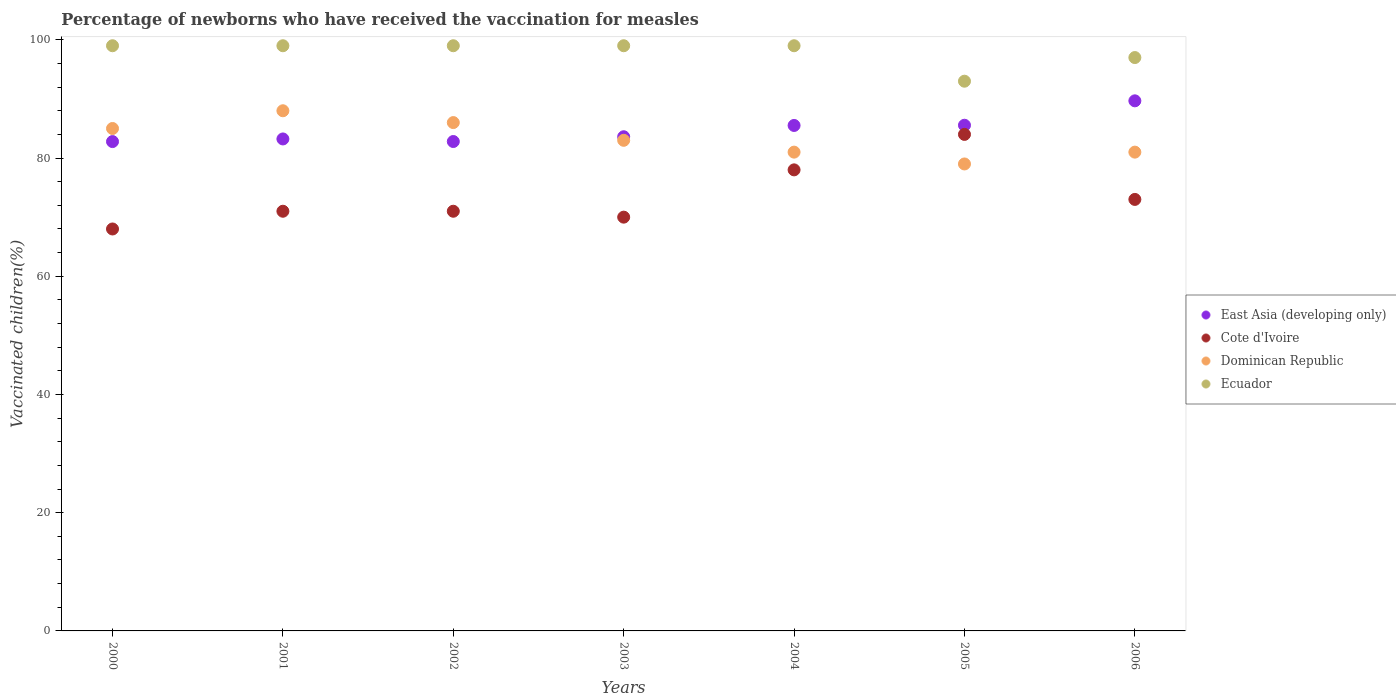How many different coloured dotlines are there?
Offer a terse response. 4. Is the number of dotlines equal to the number of legend labels?
Keep it short and to the point. Yes. What is the percentage of vaccinated children in Cote d'Ivoire in 2004?
Give a very brief answer. 78. Across all years, what is the maximum percentage of vaccinated children in East Asia (developing only)?
Keep it short and to the point. 89.68. What is the total percentage of vaccinated children in Ecuador in the graph?
Give a very brief answer. 685. What is the difference between the percentage of vaccinated children in Dominican Republic in 2004 and that in 2005?
Make the answer very short. 2. What is the difference between the percentage of vaccinated children in Cote d'Ivoire in 2006 and the percentage of vaccinated children in East Asia (developing only) in 2001?
Your answer should be very brief. -10.23. What is the average percentage of vaccinated children in Dominican Republic per year?
Ensure brevity in your answer.  83.29. What is the ratio of the percentage of vaccinated children in Cote d'Ivoire in 2001 to that in 2005?
Offer a terse response. 0.85. Is the percentage of vaccinated children in East Asia (developing only) in 2000 less than that in 2006?
Your answer should be compact. Yes. What is the difference between the highest and the second highest percentage of vaccinated children in East Asia (developing only)?
Offer a very short reply. 4.13. What is the difference between the highest and the lowest percentage of vaccinated children in Ecuador?
Ensure brevity in your answer.  6. Is it the case that in every year, the sum of the percentage of vaccinated children in East Asia (developing only) and percentage of vaccinated children in Dominican Republic  is greater than the percentage of vaccinated children in Ecuador?
Give a very brief answer. Yes. Does the percentage of vaccinated children in Dominican Republic monotonically increase over the years?
Offer a terse response. No. How many dotlines are there?
Make the answer very short. 4. What is the difference between two consecutive major ticks on the Y-axis?
Give a very brief answer. 20. Are the values on the major ticks of Y-axis written in scientific E-notation?
Give a very brief answer. No. Does the graph contain grids?
Your response must be concise. No. Where does the legend appear in the graph?
Provide a succinct answer. Center right. How are the legend labels stacked?
Offer a very short reply. Vertical. What is the title of the graph?
Ensure brevity in your answer.  Percentage of newborns who have received the vaccination for measles. Does "Estonia" appear as one of the legend labels in the graph?
Provide a succinct answer. No. What is the label or title of the Y-axis?
Provide a succinct answer. Vaccinated children(%). What is the Vaccinated children(%) of East Asia (developing only) in 2000?
Make the answer very short. 82.79. What is the Vaccinated children(%) of East Asia (developing only) in 2001?
Make the answer very short. 83.23. What is the Vaccinated children(%) in Cote d'Ivoire in 2001?
Your answer should be compact. 71. What is the Vaccinated children(%) in East Asia (developing only) in 2002?
Provide a succinct answer. 82.8. What is the Vaccinated children(%) of Dominican Republic in 2002?
Keep it short and to the point. 86. What is the Vaccinated children(%) of East Asia (developing only) in 2003?
Offer a terse response. 83.6. What is the Vaccinated children(%) in Dominican Republic in 2003?
Provide a short and direct response. 83. What is the Vaccinated children(%) of East Asia (developing only) in 2004?
Offer a terse response. 85.51. What is the Vaccinated children(%) of Dominican Republic in 2004?
Offer a very short reply. 81. What is the Vaccinated children(%) of East Asia (developing only) in 2005?
Offer a terse response. 85.55. What is the Vaccinated children(%) of Cote d'Ivoire in 2005?
Provide a succinct answer. 84. What is the Vaccinated children(%) in Dominican Republic in 2005?
Your response must be concise. 79. What is the Vaccinated children(%) in Ecuador in 2005?
Your answer should be compact. 93. What is the Vaccinated children(%) of East Asia (developing only) in 2006?
Your answer should be very brief. 89.68. What is the Vaccinated children(%) in Ecuador in 2006?
Make the answer very short. 97. Across all years, what is the maximum Vaccinated children(%) of East Asia (developing only)?
Give a very brief answer. 89.68. Across all years, what is the maximum Vaccinated children(%) of Cote d'Ivoire?
Provide a succinct answer. 84. Across all years, what is the maximum Vaccinated children(%) in Ecuador?
Provide a succinct answer. 99. Across all years, what is the minimum Vaccinated children(%) of East Asia (developing only)?
Offer a very short reply. 82.79. Across all years, what is the minimum Vaccinated children(%) of Dominican Republic?
Offer a very short reply. 79. Across all years, what is the minimum Vaccinated children(%) of Ecuador?
Make the answer very short. 93. What is the total Vaccinated children(%) of East Asia (developing only) in the graph?
Offer a terse response. 593.16. What is the total Vaccinated children(%) of Cote d'Ivoire in the graph?
Offer a very short reply. 515. What is the total Vaccinated children(%) in Dominican Republic in the graph?
Offer a very short reply. 583. What is the total Vaccinated children(%) of Ecuador in the graph?
Give a very brief answer. 685. What is the difference between the Vaccinated children(%) of East Asia (developing only) in 2000 and that in 2001?
Provide a short and direct response. -0.44. What is the difference between the Vaccinated children(%) in Ecuador in 2000 and that in 2001?
Make the answer very short. 0. What is the difference between the Vaccinated children(%) in East Asia (developing only) in 2000 and that in 2002?
Provide a succinct answer. -0.01. What is the difference between the Vaccinated children(%) of Cote d'Ivoire in 2000 and that in 2002?
Give a very brief answer. -3. What is the difference between the Vaccinated children(%) of Dominican Republic in 2000 and that in 2002?
Your answer should be compact. -1. What is the difference between the Vaccinated children(%) in Ecuador in 2000 and that in 2002?
Provide a succinct answer. 0. What is the difference between the Vaccinated children(%) in East Asia (developing only) in 2000 and that in 2003?
Offer a very short reply. -0.82. What is the difference between the Vaccinated children(%) in Dominican Republic in 2000 and that in 2003?
Make the answer very short. 2. What is the difference between the Vaccinated children(%) in East Asia (developing only) in 2000 and that in 2004?
Ensure brevity in your answer.  -2.73. What is the difference between the Vaccinated children(%) of Dominican Republic in 2000 and that in 2004?
Your answer should be very brief. 4. What is the difference between the Vaccinated children(%) in Ecuador in 2000 and that in 2004?
Ensure brevity in your answer.  0. What is the difference between the Vaccinated children(%) of East Asia (developing only) in 2000 and that in 2005?
Offer a very short reply. -2.76. What is the difference between the Vaccinated children(%) in Dominican Republic in 2000 and that in 2005?
Give a very brief answer. 6. What is the difference between the Vaccinated children(%) in Ecuador in 2000 and that in 2005?
Make the answer very short. 6. What is the difference between the Vaccinated children(%) of East Asia (developing only) in 2000 and that in 2006?
Provide a short and direct response. -6.89. What is the difference between the Vaccinated children(%) of Dominican Republic in 2000 and that in 2006?
Keep it short and to the point. 4. What is the difference between the Vaccinated children(%) in Ecuador in 2000 and that in 2006?
Provide a succinct answer. 2. What is the difference between the Vaccinated children(%) of East Asia (developing only) in 2001 and that in 2002?
Give a very brief answer. 0.43. What is the difference between the Vaccinated children(%) of Dominican Republic in 2001 and that in 2002?
Give a very brief answer. 2. What is the difference between the Vaccinated children(%) of East Asia (developing only) in 2001 and that in 2003?
Provide a succinct answer. -0.37. What is the difference between the Vaccinated children(%) of Dominican Republic in 2001 and that in 2003?
Give a very brief answer. 5. What is the difference between the Vaccinated children(%) in Ecuador in 2001 and that in 2003?
Keep it short and to the point. 0. What is the difference between the Vaccinated children(%) of East Asia (developing only) in 2001 and that in 2004?
Make the answer very short. -2.28. What is the difference between the Vaccinated children(%) of Dominican Republic in 2001 and that in 2004?
Your response must be concise. 7. What is the difference between the Vaccinated children(%) in Ecuador in 2001 and that in 2004?
Offer a very short reply. 0. What is the difference between the Vaccinated children(%) of East Asia (developing only) in 2001 and that in 2005?
Keep it short and to the point. -2.32. What is the difference between the Vaccinated children(%) of Dominican Republic in 2001 and that in 2005?
Provide a short and direct response. 9. What is the difference between the Vaccinated children(%) in East Asia (developing only) in 2001 and that in 2006?
Offer a terse response. -6.45. What is the difference between the Vaccinated children(%) in Cote d'Ivoire in 2001 and that in 2006?
Ensure brevity in your answer.  -2. What is the difference between the Vaccinated children(%) in Dominican Republic in 2001 and that in 2006?
Keep it short and to the point. 7. What is the difference between the Vaccinated children(%) in East Asia (developing only) in 2002 and that in 2003?
Ensure brevity in your answer.  -0.81. What is the difference between the Vaccinated children(%) of Dominican Republic in 2002 and that in 2003?
Provide a succinct answer. 3. What is the difference between the Vaccinated children(%) of East Asia (developing only) in 2002 and that in 2004?
Your answer should be very brief. -2.72. What is the difference between the Vaccinated children(%) of Cote d'Ivoire in 2002 and that in 2004?
Your answer should be very brief. -7. What is the difference between the Vaccinated children(%) of Dominican Republic in 2002 and that in 2004?
Give a very brief answer. 5. What is the difference between the Vaccinated children(%) in Ecuador in 2002 and that in 2004?
Make the answer very short. 0. What is the difference between the Vaccinated children(%) in East Asia (developing only) in 2002 and that in 2005?
Keep it short and to the point. -2.75. What is the difference between the Vaccinated children(%) in Dominican Republic in 2002 and that in 2005?
Make the answer very short. 7. What is the difference between the Vaccinated children(%) in East Asia (developing only) in 2002 and that in 2006?
Give a very brief answer. -6.88. What is the difference between the Vaccinated children(%) of Cote d'Ivoire in 2002 and that in 2006?
Make the answer very short. -2. What is the difference between the Vaccinated children(%) of Ecuador in 2002 and that in 2006?
Offer a very short reply. 2. What is the difference between the Vaccinated children(%) of East Asia (developing only) in 2003 and that in 2004?
Your answer should be very brief. -1.91. What is the difference between the Vaccinated children(%) in Ecuador in 2003 and that in 2004?
Keep it short and to the point. 0. What is the difference between the Vaccinated children(%) in East Asia (developing only) in 2003 and that in 2005?
Provide a short and direct response. -1.95. What is the difference between the Vaccinated children(%) of East Asia (developing only) in 2003 and that in 2006?
Ensure brevity in your answer.  -6.08. What is the difference between the Vaccinated children(%) in Cote d'Ivoire in 2003 and that in 2006?
Make the answer very short. -3. What is the difference between the Vaccinated children(%) in Dominican Republic in 2003 and that in 2006?
Provide a succinct answer. 2. What is the difference between the Vaccinated children(%) of Ecuador in 2003 and that in 2006?
Give a very brief answer. 2. What is the difference between the Vaccinated children(%) of East Asia (developing only) in 2004 and that in 2005?
Offer a terse response. -0.04. What is the difference between the Vaccinated children(%) of Cote d'Ivoire in 2004 and that in 2005?
Make the answer very short. -6. What is the difference between the Vaccinated children(%) of Ecuador in 2004 and that in 2005?
Your answer should be very brief. 6. What is the difference between the Vaccinated children(%) in East Asia (developing only) in 2004 and that in 2006?
Keep it short and to the point. -4.17. What is the difference between the Vaccinated children(%) in Ecuador in 2004 and that in 2006?
Offer a terse response. 2. What is the difference between the Vaccinated children(%) in East Asia (developing only) in 2005 and that in 2006?
Provide a succinct answer. -4.13. What is the difference between the Vaccinated children(%) of Dominican Republic in 2005 and that in 2006?
Your answer should be compact. -2. What is the difference between the Vaccinated children(%) of Ecuador in 2005 and that in 2006?
Offer a terse response. -4. What is the difference between the Vaccinated children(%) of East Asia (developing only) in 2000 and the Vaccinated children(%) of Cote d'Ivoire in 2001?
Your answer should be compact. 11.79. What is the difference between the Vaccinated children(%) in East Asia (developing only) in 2000 and the Vaccinated children(%) in Dominican Republic in 2001?
Your answer should be compact. -5.21. What is the difference between the Vaccinated children(%) in East Asia (developing only) in 2000 and the Vaccinated children(%) in Ecuador in 2001?
Provide a succinct answer. -16.21. What is the difference between the Vaccinated children(%) of Cote d'Ivoire in 2000 and the Vaccinated children(%) of Dominican Republic in 2001?
Offer a very short reply. -20. What is the difference between the Vaccinated children(%) in Cote d'Ivoire in 2000 and the Vaccinated children(%) in Ecuador in 2001?
Your answer should be compact. -31. What is the difference between the Vaccinated children(%) in East Asia (developing only) in 2000 and the Vaccinated children(%) in Cote d'Ivoire in 2002?
Your answer should be compact. 11.79. What is the difference between the Vaccinated children(%) in East Asia (developing only) in 2000 and the Vaccinated children(%) in Dominican Republic in 2002?
Keep it short and to the point. -3.21. What is the difference between the Vaccinated children(%) in East Asia (developing only) in 2000 and the Vaccinated children(%) in Ecuador in 2002?
Provide a succinct answer. -16.21. What is the difference between the Vaccinated children(%) of Cote d'Ivoire in 2000 and the Vaccinated children(%) of Dominican Republic in 2002?
Your response must be concise. -18. What is the difference between the Vaccinated children(%) in Cote d'Ivoire in 2000 and the Vaccinated children(%) in Ecuador in 2002?
Keep it short and to the point. -31. What is the difference between the Vaccinated children(%) of East Asia (developing only) in 2000 and the Vaccinated children(%) of Cote d'Ivoire in 2003?
Ensure brevity in your answer.  12.79. What is the difference between the Vaccinated children(%) in East Asia (developing only) in 2000 and the Vaccinated children(%) in Dominican Republic in 2003?
Your answer should be compact. -0.21. What is the difference between the Vaccinated children(%) of East Asia (developing only) in 2000 and the Vaccinated children(%) of Ecuador in 2003?
Give a very brief answer. -16.21. What is the difference between the Vaccinated children(%) in Cote d'Ivoire in 2000 and the Vaccinated children(%) in Ecuador in 2003?
Give a very brief answer. -31. What is the difference between the Vaccinated children(%) of East Asia (developing only) in 2000 and the Vaccinated children(%) of Cote d'Ivoire in 2004?
Keep it short and to the point. 4.79. What is the difference between the Vaccinated children(%) of East Asia (developing only) in 2000 and the Vaccinated children(%) of Dominican Republic in 2004?
Your answer should be compact. 1.79. What is the difference between the Vaccinated children(%) in East Asia (developing only) in 2000 and the Vaccinated children(%) in Ecuador in 2004?
Your response must be concise. -16.21. What is the difference between the Vaccinated children(%) in Cote d'Ivoire in 2000 and the Vaccinated children(%) in Ecuador in 2004?
Your answer should be compact. -31. What is the difference between the Vaccinated children(%) of East Asia (developing only) in 2000 and the Vaccinated children(%) of Cote d'Ivoire in 2005?
Ensure brevity in your answer.  -1.21. What is the difference between the Vaccinated children(%) of East Asia (developing only) in 2000 and the Vaccinated children(%) of Dominican Republic in 2005?
Your response must be concise. 3.79. What is the difference between the Vaccinated children(%) of East Asia (developing only) in 2000 and the Vaccinated children(%) of Ecuador in 2005?
Make the answer very short. -10.21. What is the difference between the Vaccinated children(%) in Cote d'Ivoire in 2000 and the Vaccinated children(%) in Dominican Republic in 2005?
Ensure brevity in your answer.  -11. What is the difference between the Vaccinated children(%) in Dominican Republic in 2000 and the Vaccinated children(%) in Ecuador in 2005?
Provide a short and direct response. -8. What is the difference between the Vaccinated children(%) in East Asia (developing only) in 2000 and the Vaccinated children(%) in Cote d'Ivoire in 2006?
Make the answer very short. 9.79. What is the difference between the Vaccinated children(%) in East Asia (developing only) in 2000 and the Vaccinated children(%) in Dominican Republic in 2006?
Provide a short and direct response. 1.79. What is the difference between the Vaccinated children(%) of East Asia (developing only) in 2000 and the Vaccinated children(%) of Ecuador in 2006?
Make the answer very short. -14.21. What is the difference between the Vaccinated children(%) in Cote d'Ivoire in 2000 and the Vaccinated children(%) in Ecuador in 2006?
Keep it short and to the point. -29. What is the difference between the Vaccinated children(%) in East Asia (developing only) in 2001 and the Vaccinated children(%) in Cote d'Ivoire in 2002?
Make the answer very short. 12.23. What is the difference between the Vaccinated children(%) in East Asia (developing only) in 2001 and the Vaccinated children(%) in Dominican Republic in 2002?
Keep it short and to the point. -2.77. What is the difference between the Vaccinated children(%) in East Asia (developing only) in 2001 and the Vaccinated children(%) in Ecuador in 2002?
Make the answer very short. -15.77. What is the difference between the Vaccinated children(%) in Cote d'Ivoire in 2001 and the Vaccinated children(%) in Dominican Republic in 2002?
Provide a succinct answer. -15. What is the difference between the Vaccinated children(%) of Cote d'Ivoire in 2001 and the Vaccinated children(%) of Ecuador in 2002?
Offer a terse response. -28. What is the difference between the Vaccinated children(%) of East Asia (developing only) in 2001 and the Vaccinated children(%) of Cote d'Ivoire in 2003?
Your answer should be very brief. 13.23. What is the difference between the Vaccinated children(%) in East Asia (developing only) in 2001 and the Vaccinated children(%) in Dominican Republic in 2003?
Ensure brevity in your answer.  0.23. What is the difference between the Vaccinated children(%) of East Asia (developing only) in 2001 and the Vaccinated children(%) of Ecuador in 2003?
Your answer should be compact. -15.77. What is the difference between the Vaccinated children(%) in Cote d'Ivoire in 2001 and the Vaccinated children(%) in Ecuador in 2003?
Make the answer very short. -28. What is the difference between the Vaccinated children(%) in Dominican Republic in 2001 and the Vaccinated children(%) in Ecuador in 2003?
Offer a terse response. -11. What is the difference between the Vaccinated children(%) in East Asia (developing only) in 2001 and the Vaccinated children(%) in Cote d'Ivoire in 2004?
Provide a short and direct response. 5.23. What is the difference between the Vaccinated children(%) of East Asia (developing only) in 2001 and the Vaccinated children(%) of Dominican Republic in 2004?
Give a very brief answer. 2.23. What is the difference between the Vaccinated children(%) in East Asia (developing only) in 2001 and the Vaccinated children(%) in Ecuador in 2004?
Provide a short and direct response. -15.77. What is the difference between the Vaccinated children(%) in Cote d'Ivoire in 2001 and the Vaccinated children(%) in Ecuador in 2004?
Ensure brevity in your answer.  -28. What is the difference between the Vaccinated children(%) of Dominican Republic in 2001 and the Vaccinated children(%) of Ecuador in 2004?
Keep it short and to the point. -11. What is the difference between the Vaccinated children(%) in East Asia (developing only) in 2001 and the Vaccinated children(%) in Cote d'Ivoire in 2005?
Make the answer very short. -0.77. What is the difference between the Vaccinated children(%) in East Asia (developing only) in 2001 and the Vaccinated children(%) in Dominican Republic in 2005?
Keep it short and to the point. 4.23. What is the difference between the Vaccinated children(%) of East Asia (developing only) in 2001 and the Vaccinated children(%) of Ecuador in 2005?
Your response must be concise. -9.77. What is the difference between the Vaccinated children(%) of Cote d'Ivoire in 2001 and the Vaccinated children(%) of Dominican Republic in 2005?
Give a very brief answer. -8. What is the difference between the Vaccinated children(%) in Cote d'Ivoire in 2001 and the Vaccinated children(%) in Ecuador in 2005?
Your response must be concise. -22. What is the difference between the Vaccinated children(%) of Dominican Republic in 2001 and the Vaccinated children(%) of Ecuador in 2005?
Your answer should be very brief. -5. What is the difference between the Vaccinated children(%) in East Asia (developing only) in 2001 and the Vaccinated children(%) in Cote d'Ivoire in 2006?
Give a very brief answer. 10.23. What is the difference between the Vaccinated children(%) of East Asia (developing only) in 2001 and the Vaccinated children(%) of Dominican Republic in 2006?
Provide a succinct answer. 2.23. What is the difference between the Vaccinated children(%) in East Asia (developing only) in 2001 and the Vaccinated children(%) in Ecuador in 2006?
Your answer should be very brief. -13.77. What is the difference between the Vaccinated children(%) in Cote d'Ivoire in 2001 and the Vaccinated children(%) in Ecuador in 2006?
Offer a very short reply. -26. What is the difference between the Vaccinated children(%) in Dominican Republic in 2001 and the Vaccinated children(%) in Ecuador in 2006?
Give a very brief answer. -9. What is the difference between the Vaccinated children(%) in East Asia (developing only) in 2002 and the Vaccinated children(%) in Cote d'Ivoire in 2003?
Your answer should be compact. 12.8. What is the difference between the Vaccinated children(%) of East Asia (developing only) in 2002 and the Vaccinated children(%) of Dominican Republic in 2003?
Offer a very short reply. -0.2. What is the difference between the Vaccinated children(%) in East Asia (developing only) in 2002 and the Vaccinated children(%) in Ecuador in 2003?
Ensure brevity in your answer.  -16.2. What is the difference between the Vaccinated children(%) of Cote d'Ivoire in 2002 and the Vaccinated children(%) of Dominican Republic in 2003?
Your response must be concise. -12. What is the difference between the Vaccinated children(%) of Dominican Republic in 2002 and the Vaccinated children(%) of Ecuador in 2003?
Your answer should be compact. -13. What is the difference between the Vaccinated children(%) in East Asia (developing only) in 2002 and the Vaccinated children(%) in Cote d'Ivoire in 2004?
Give a very brief answer. 4.8. What is the difference between the Vaccinated children(%) in East Asia (developing only) in 2002 and the Vaccinated children(%) in Dominican Republic in 2004?
Your answer should be very brief. 1.8. What is the difference between the Vaccinated children(%) of East Asia (developing only) in 2002 and the Vaccinated children(%) of Ecuador in 2004?
Provide a short and direct response. -16.2. What is the difference between the Vaccinated children(%) of East Asia (developing only) in 2002 and the Vaccinated children(%) of Cote d'Ivoire in 2005?
Give a very brief answer. -1.2. What is the difference between the Vaccinated children(%) of East Asia (developing only) in 2002 and the Vaccinated children(%) of Dominican Republic in 2005?
Give a very brief answer. 3.8. What is the difference between the Vaccinated children(%) in East Asia (developing only) in 2002 and the Vaccinated children(%) in Ecuador in 2005?
Keep it short and to the point. -10.2. What is the difference between the Vaccinated children(%) in Cote d'Ivoire in 2002 and the Vaccinated children(%) in Dominican Republic in 2005?
Keep it short and to the point. -8. What is the difference between the Vaccinated children(%) in Cote d'Ivoire in 2002 and the Vaccinated children(%) in Ecuador in 2005?
Your response must be concise. -22. What is the difference between the Vaccinated children(%) of Dominican Republic in 2002 and the Vaccinated children(%) of Ecuador in 2005?
Keep it short and to the point. -7. What is the difference between the Vaccinated children(%) in East Asia (developing only) in 2002 and the Vaccinated children(%) in Cote d'Ivoire in 2006?
Make the answer very short. 9.8. What is the difference between the Vaccinated children(%) of East Asia (developing only) in 2002 and the Vaccinated children(%) of Dominican Republic in 2006?
Keep it short and to the point. 1.8. What is the difference between the Vaccinated children(%) of East Asia (developing only) in 2002 and the Vaccinated children(%) of Ecuador in 2006?
Provide a short and direct response. -14.2. What is the difference between the Vaccinated children(%) of East Asia (developing only) in 2003 and the Vaccinated children(%) of Cote d'Ivoire in 2004?
Give a very brief answer. 5.6. What is the difference between the Vaccinated children(%) of East Asia (developing only) in 2003 and the Vaccinated children(%) of Dominican Republic in 2004?
Your answer should be very brief. 2.6. What is the difference between the Vaccinated children(%) in East Asia (developing only) in 2003 and the Vaccinated children(%) in Ecuador in 2004?
Provide a succinct answer. -15.4. What is the difference between the Vaccinated children(%) in Cote d'Ivoire in 2003 and the Vaccinated children(%) in Dominican Republic in 2004?
Your response must be concise. -11. What is the difference between the Vaccinated children(%) of Cote d'Ivoire in 2003 and the Vaccinated children(%) of Ecuador in 2004?
Offer a very short reply. -29. What is the difference between the Vaccinated children(%) in Dominican Republic in 2003 and the Vaccinated children(%) in Ecuador in 2004?
Provide a short and direct response. -16. What is the difference between the Vaccinated children(%) of East Asia (developing only) in 2003 and the Vaccinated children(%) of Cote d'Ivoire in 2005?
Your answer should be very brief. -0.4. What is the difference between the Vaccinated children(%) of East Asia (developing only) in 2003 and the Vaccinated children(%) of Dominican Republic in 2005?
Provide a short and direct response. 4.6. What is the difference between the Vaccinated children(%) in East Asia (developing only) in 2003 and the Vaccinated children(%) in Ecuador in 2005?
Offer a terse response. -9.4. What is the difference between the Vaccinated children(%) in Cote d'Ivoire in 2003 and the Vaccinated children(%) in Dominican Republic in 2005?
Provide a succinct answer. -9. What is the difference between the Vaccinated children(%) of Cote d'Ivoire in 2003 and the Vaccinated children(%) of Ecuador in 2005?
Your answer should be very brief. -23. What is the difference between the Vaccinated children(%) of Dominican Republic in 2003 and the Vaccinated children(%) of Ecuador in 2005?
Keep it short and to the point. -10. What is the difference between the Vaccinated children(%) in East Asia (developing only) in 2003 and the Vaccinated children(%) in Cote d'Ivoire in 2006?
Offer a terse response. 10.6. What is the difference between the Vaccinated children(%) of East Asia (developing only) in 2003 and the Vaccinated children(%) of Dominican Republic in 2006?
Keep it short and to the point. 2.6. What is the difference between the Vaccinated children(%) in East Asia (developing only) in 2003 and the Vaccinated children(%) in Ecuador in 2006?
Your response must be concise. -13.4. What is the difference between the Vaccinated children(%) of Cote d'Ivoire in 2003 and the Vaccinated children(%) of Ecuador in 2006?
Give a very brief answer. -27. What is the difference between the Vaccinated children(%) in Dominican Republic in 2003 and the Vaccinated children(%) in Ecuador in 2006?
Offer a terse response. -14. What is the difference between the Vaccinated children(%) in East Asia (developing only) in 2004 and the Vaccinated children(%) in Cote d'Ivoire in 2005?
Your answer should be very brief. 1.51. What is the difference between the Vaccinated children(%) in East Asia (developing only) in 2004 and the Vaccinated children(%) in Dominican Republic in 2005?
Your answer should be compact. 6.51. What is the difference between the Vaccinated children(%) of East Asia (developing only) in 2004 and the Vaccinated children(%) of Ecuador in 2005?
Your answer should be very brief. -7.49. What is the difference between the Vaccinated children(%) in Cote d'Ivoire in 2004 and the Vaccinated children(%) in Ecuador in 2005?
Offer a terse response. -15. What is the difference between the Vaccinated children(%) in East Asia (developing only) in 2004 and the Vaccinated children(%) in Cote d'Ivoire in 2006?
Your answer should be very brief. 12.51. What is the difference between the Vaccinated children(%) of East Asia (developing only) in 2004 and the Vaccinated children(%) of Dominican Republic in 2006?
Your response must be concise. 4.51. What is the difference between the Vaccinated children(%) in East Asia (developing only) in 2004 and the Vaccinated children(%) in Ecuador in 2006?
Ensure brevity in your answer.  -11.49. What is the difference between the Vaccinated children(%) of Cote d'Ivoire in 2004 and the Vaccinated children(%) of Dominican Republic in 2006?
Keep it short and to the point. -3. What is the difference between the Vaccinated children(%) in Cote d'Ivoire in 2004 and the Vaccinated children(%) in Ecuador in 2006?
Provide a short and direct response. -19. What is the difference between the Vaccinated children(%) in Dominican Republic in 2004 and the Vaccinated children(%) in Ecuador in 2006?
Keep it short and to the point. -16. What is the difference between the Vaccinated children(%) of East Asia (developing only) in 2005 and the Vaccinated children(%) of Cote d'Ivoire in 2006?
Your answer should be very brief. 12.55. What is the difference between the Vaccinated children(%) in East Asia (developing only) in 2005 and the Vaccinated children(%) in Dominican Republic in 2006?
Provide a succinct answer. 4.55. What is the difference between the Vaccinated children(%) of East Asia (developing only) in 2005 and the Vaccinated children(%) of Ecuador in 2006?
Your response must be concise. -11.45. What is the difference between the Vaccinated children(%) of Cote d'Ivoire in 2005 and the Vaccinated children(%) of Dominican Republic in 2006?
Give a very brief answer. 3. What is the difference between the Vaccinated children(%) in Dominican Republic in 2005 and the Vaccinated children(%) in Ecuador in 2006?
Provide a short and direct response. -18. What is the average Vaccinated children(%) of East Asia (developing only) per year?
Your response must be concise. 84.74. What is the average Vaccinated children(%) in Cote d'Ivoire per year?
Make the answer very short. 73.57. What is the average Vaccinated children(%) in Dominican Republic per year?
Your answer should be compact. 83.29. What is the average Vaccinated children(%) in Ecuador per year?
Keep it short and to the point. 97.86. In the year 2000, what is the difference between the Vaccinated children(%) in East Asia (developing only) and Vaccinated children(%) in Cote d'Ivoire?
Make the answer very short. 14.79. In the year 2000, what is the difference between the Vaccinated children(%) of East Asia (developing only) and Vaccinated children(%) of Dominican Republic?
Give a very brief answer. -2.21. In the year 2000, what is the difference between the Vaccinated children(%) in East Asia (developing only) and Vaccinated children(%) in Ecuador?
Your response must be concise. -16.21. In the year 2000, what is the difference between the Vaccinated children(%) in Cote d'Ivoire and Vaccinated children(%) in Ecuador?
Provide a succinct answer. -31. In the year 2001, what is the difference between the Vaccinated children(%) of East Asia (developing only) and Vaccinated children(%) of Cote d'Ivoire?
Provide a succinct answer. 12.23. In the year 2001, what is the difference between the Vaccinated children(%) of East Asia (developing only) and Vaccinated children(%) of Dominican Republic?
Your answer should be very brief. -4.77. In the year 2001, what is the difference between the Vaccinated children(%) in East Asia (developing only) and Vaccinated children(%) in Ecuador?
Your response must be concise. -15.77. In the year 2002, what is the difference between the Vaccinated children(%) in East Asia (developing only) and Vaccinated children(%) in Cote d'Ivoire?
Ensure brevity in your answer.  11.8. In the year 2002, what is the difference between the Vaccinated children(%) of East Asia (developing only) and Vaccinated children(%) of Dominican Republic?
Your response must be concise. -3.2. In the year 2002, what is the difference between the Vaccinated children(%) of East Asia (developing only) and Vaccinated children(%) of Ecuador?
Give a very brief answer. -16.2. In the year 2002, what is the difference between the Vaccinated children(%) of Cote d'Ivoire and Vaccinated children(%) of Dominican Republic?
Provide a succinct answer. -15. In the year 2002, what is the difference between the Vaccinated children(%) in Cote d'Ivoire and Vaccinated children(%) in Ecuador?
Your answer should be compact. -28. In the year 2002, what is the difference between the Vaccinated children(%) of Dominican Republic and Vaccinated children(%) of Ecuador?
Ensure brevity in your answer.  -13. In the year 2003, what is the difference between the Vaccinated children(%) of East Asia (developing only) and Vaccinated children(%) of Cote d'Ivoire?
Ensure brevity in your answer.  13.6. In the year 2003, what is the difference between the Vaccinated children(%) in East Asia (developing only) and Vaccinated children(%) in Dominican Republic?
Keep it short and to the point. 0.6. In the year 2003, what is the difference between the Vaccinated children(%) of East Asia (developing only) and Vaccinated children(%) of Ecuador?
Your answer should be compact. -15.4. In the year 2003, what is the difference between the Vaccinated children(%) of Cote d'Ivoire and Vaccinated children(%) of Ecuador?
Offer a terse response. -29. In the year 2003, what is the difference between the Vaccinated children(%) of Dominican Republic and Vaccinated children(%) of Ecuador?
Your answer should be very brief. -16. In the year 2004, what is the difference between the Vaccinated children(%) of East Asia (developing only) and Vaccinated children(%) of Cote d'Ivoire?
Ensure brevity in your answer.  7.51. In the year 2004, what is the difference between the Vaccinated children(%) in East Asia (developing only) and Vaccinated children(%) in Dominican Republic?
Ensure brevity in your answer.  4.51. In the year 2004, what is the difference between the Vaccinated children(%) of East Asia (developing only) and Vaccinated children(%) of Ecuador?
Your answer should be compact. -13.49. In the year 2004, what is the difference between the Vaccinated children(%) of Cote d'Ivoire and Vaccinated children(%) of Dominican Republic?
Offer a very short reply. -3. In the year 2004, what is the difference between the Vaccinated children(%) in Dominican Republic and Vaccinated children(%) in Ecuador?
Ensure brevity in your answer.  -18. In the year 2005, what is the difference between the Vaccinated children(%) of East Asia (developing only) and Vaccinated children(%) of Cote d'Ivoire?
Your answer should be very brief. 1.55. In the year 2005, what is the difference between the Vaccinated children(%) of East Asia (developing only) and Vaccinated children(%) of Dominican Republic?
Provide a succinct answer. 6.55. In the year 2005, what is the difference between the Vaccinated children(%) of East Asia (developing only) and Vaccinated children(%) of Ecuador?
Provide a short and direct response. -7.45. In the year 2006, what is the difference between the Vaccinated children(%) in East Asia (developing only) and Vaccinated children(%) in Cote d'Ivoire?
Make the answer very short. 16.68. In the year 2006, what is the difference between the Vaccinated children(%) of East Asia (developing only) and Vaccinated children(%) of Dominican Republic?
Your answer should be very brief. 8.68. In the year 2006, what is the difference between the Vaccinated children(%) in East Asia (developing only) and Vaccinated children(%) in Ecuador?
Ensure brevity in your answer.  -7.32. In the year 2006, what is the difference between the Vaccinated children(%) in Cote d'Ivoire and Vaccinated children(%) in Dominican Republic?
Your answer should be compact. -8. What is the ratio of the Vaccinated children(%) of Cote d'Ivoire in 2000 to that in 2001?
Offer a very short reply. 0.96. What is the ratio of the Vaccinated children(%) of Dominican Republic in 2000 to that in 2001?
Provide a succinct answer. 0.97. What is the ratio of the Vaccinated children(%) of Ecuador in 2000 to that in 2001?
Offer a very short reply. 1. What is the ratio of the Vaccinated children(%) in Cote d'Ivoire in 2000 to that in 2002?
Your response must be concise. 0.96. What is the ratio of the Vaccinated children(%) of Dominican Republic in 2000 to that in 2002?
Your answer should be compact. 0.99. What is the ratio of the Vaccinated children(%) in East Asia (developing only) in 2000 to that in 2003?
Your answer should be compact. 0.99. What is the ratio of the Vaccinated children(%) of Cote d'Ivoire in 2000 to that in 2003?
Provide a short and direct response. 0.97. What is the ratio of the Vaccinated children(%) of Dominican Republic in 2000 to that in 2003?
Your answer should be very brief. 1.02. What is the ratio of the Vaccinated children(%) in East Asia (developing only) in 2000 to that in 2004?
Your answer should be very brief. 0.97. What is the ratio of the Vaccinated children(%) of Cote d'Ivoire in 2000 to that in 2004?
Provide a short and direct response. 0.87. What is the ratio of the Vaccinated children(%) of Dominican Republic in 2000 to that in 2004?
Give a very brief answer. 1.05. What is the ratio of the Vaccinated children(%) of Ecuador in 2000 to that in 2004?
Your response must be concise. 1. What is the ratio of the Vaccinated children(%) in East Asia (developing only) in 2000 to that in 2005?
Offer a very short reply. 0.97. What is the ratio of the Vaccinated children(%) of Cote d'Ivoire in 2000 to that in 2005?
Your response must be concise. 0.81. What is the ratio of the Vaccinated children(%) of Dominican Republic in 2000 to that in 2005?
Offer a terse response. 1.08. What is the ratio of the Vaccinated children(%) of Ecuador in 2000 to that in 2005?
Provide a succinct answer. 1.06. What is the ratio of the Vaccinated children(%) of Cote d'Ivoire in 2000 to that in 2006?
Provide a succinct answer. 0.93. What is the ratio of the Vaccinated children(%) of Dominican Republic in 2000 to that in 2006?
Keep it short and to the point. 1.05. What is the ratio of the Vaccinated children(%) of Ecuador in 2000 to that in 2006?
Ensure brevity in your answer.  1.02. What is the ratio of the Vaccinated children(%) of Dominican Republic in 2001 to that in 2002?
Offer a terse response. 1.02. What is the ratio of the Vaccinated children(%) in Ecuador in 2001 to that in 2002?
Your answer should be compact. 1. What is the ratio of the Vaccinated children(%) of Cote d'Ivoire in 2001 to that in 2003?
Make the answer very short. 1.01. What is the ratio of the Vaccinated children(%) in Dominican Republic in 2001 to that in 2003?
Keep it short and to the point. 1.06. What is the ratio of the Vaccinated children(%) in Ecuador in 2001 to that in 2003?
Provide a short and direct response. 1. What is the ratio of the Vaccinated children(%) of East Asia (developing only) in 2001 to that in 2004?
Provide a succinct answer. 0.97. What is the ratio of the Vaccinated children(%) of Cote d'Ivoire in 2001 to that in 2004?
Give a very brief answer. 0.91. What is the ratio of the Vaccinated children(%) of Dominican Republic in 2001 to that in 2004?
Make the answer very short. 1.09. What is the ratio of the Vaccinated children(%) of East Asia (developing only) in 2001 to that in 2005?
Give a very brief answer. 0.97. What is the ratio of the Vaccinated children(%) in Cote d'Ivoire in 2001 to that in 2005?
Keep it short and to the point. 0.85. What is the ratio of the Vaccinated children(%) in Dominican Republic in 2001 to that in 2005?
Provide a succinct answer. 1.11. What is the ratio of the Vaccinated children(%) of Ecuador in 2001 to that in 2005?
Ensure brevity in your answer.  1.06. What is the ratio of the Vaccinated children(%) in East Asia (developing only) in 2001 to that in 2006?
Give a very brief answer. 0.93. What is the ratio of the Vaccinated children(%) of Cote d'Ivoire in 2001 to that in 2006?
Provide a short and direct response. 0.97. What is the ratio of the Vaccinated children(%) in Dominican Republic in 2001 to that in 2006?
Keep it short and to the point. 1.09. What is the ratio of the Vaccinated children(%) in Ecuador in 2001 to that in 2006?
Give a very brief answer. 1.02. What is the ratio of the Vaccinated children(%) in Cote d'Ivoire in 2002 to that in 2003?
Make the answer very short. 1.01. What is the ratio of the Vaccinated children(%) of Dominican Republic in 2002 to that in 2003?
Keep it short and to the point. 1.04. What is the ratio of the Vaccinated children(%) in East Asia (developing only) in 2002 to that in 2004?
Ensure brevity in your answer.  0.97. What is the ratio of the Vaccinated children(%) of Cote d'Ivoire in 2002 to that in 2004?
Your answer should be compact. 0.91. What is the ratio of the Vaccinated children(%) in Dominican Republic in 2002 to that in 2004?
Your response must be concise. 1.06. What is the ratio of the Vaccinated children(%) in East Asia (developing only) in 2002 to that in 2005?
Keep it short and to the point. 0.97. What is the ratio of the Vaccinated children(%) in Cote d'Ivoire in 2002 to that in 2005?
Offer a terse response. 0.85. What is the ratio of the Vaccinated children(%) in Dominican Republic in 2002 to that in 2005?
Make the answer very short. 1.09. What is the ratio of the Vaccinated children(%) in Ecuador in 2002 to that in 2005?
Your answer should be very brief. 1.06. What is the ratio of the Vaccinated children(%) in East Asia (developing only) in 2002 to that in 2006?
Your answer should be compact. 0.92. What is the ratio of the Vaccinated children(%) in Cote d'Ivoire in 2002 to that in 2006?
Your response must be concise. 0.97. What is the ratio of the Vaccinated children(%) of Dominican Republic in 2002 to that in 2006?
Provide a succinct answer. 1.06. What is the ratio of the Vaccinated children(%) of Ecuador in 2002 to that in 2006?
Give a very brief answer. 1.02. What is the ratio of the Vaccinated children(%) in East Asia (developing only) in 2003 to that in 2004?
Your answer should be compact. 0.98. What is the ratio of the Vaccinated children(%) in Cote d'Ivoire in 2003 to that in 2004?
Provide a short and direct response. 0.9. What is the ratio of the Vaccinated children(%) in Dominican Republic in 2003 to that in 2004?
Offer a terse response. 1.02. What is the ratio of the Vaccinated children(%) of East Asia (developing only) in 2003 to that in 2005?
Keep it short and to the point. 0.98. What is the ratio of the Vaccinated children(%) of Dominican Republic in 2003 to that in 2005?
Provide a short and direct response. 1.05. What is the ratio of the Vaccinated children(%) of Ecuador in 2003 to that in 2005?
Your answer should be compact. 1.06. What is the ratio of the Vaccinated children(%) of East Asia (developing only) in 2003 to that in 2006?
Keep it short and to the point. 0.93. What is the ratio of the Vaccinated children(%) in Cote d'Ivoire in 2003 to that in 2006?
Your answer should be very brief. 0.96. What is the ratio of the Vaccinated children(%) of Dominican Republic in 2003 to that in 2006?
Offer a very short reply. 1.02. What is the ratio of the Vaccinated children(%) in Ecuador in 2003 to that in 2006?
Provide a short and direct response. 1.02. What is the ratio of the Vaccinated children(%) of East Asia (developing only) in 2004 to that in 2005?
Your answer should be compact. 1. What is the ratio of the Vaccinated children(%) in Dominican Republic in 2004 to that in 2005?
Offer a very short reply. 1.03. What is the ratio of the Vaccinated children(%) in Ecuador in 2004 to that in 2005?
Keep it short and to the point. 1.06. What is the ratio of the Vaccinated children(%) of East Asia (developing only) in 2004 to that in 2006?
Offer a very short reply. 0.95. What is the ratio of the Vaccinated children(%) of Cote d'Ivoire in 2004 to that in 2006?
Offer a very short reply. 1.07. What is the ratio of the Vaccinated children(%) of Dominican Republic in 2004 to that in 2006?
Your answer should be compact. 1. What is the ratio of the Vaccinated children(%) of Ecuador in 2004 to that in 2006?
Keep it short and to the point. 1.02. What is the ratio of the Vaccinated children(%) of East Asia (developing only) in 2005 to that in 2006?
Offer a very short reply. 0.95. What is the ratio of the Vaccinated children(%) in Cote d'Ivoire in 2005 to that in 2006?
Your answer should be compact. 1.15. What is the ratio of the Vaccinated children(%) of Dominican Republic in 2005 to that in 2006?
Provide a short and direct response. 0.98. What is the ratio of the Vaccinated children(%) in Ecuador in 2005 to that in 2006?
Give a very brief answer. 0.96. What is the difference between the highest and the second highest Vaccinated children(%) in East Asia (developing only)?
Provide a succinct answer. 4.13. What is the difference between the highest and the second highest Vaccinated children(%) in Cote d'Ivoire?
Keep it short and to the point. 6. What is the difference between the highest and the second highest Vaccinated children(%) in Ecuador?
Your answer should be compact. 0. What is the difference between the highest and the lowest Vaccinated children(%) in East Asia (developing only)?
Offer a very short reply. 6.89. What is the difference between the highest and the lowest Vaccinated children(%) of Cote d'Ivoire?
Make the answer very short. 16. What is the difference between the highest and the lowest Vaccinated children(%) of Ecuador?
Provide a succinct answer. 6. 